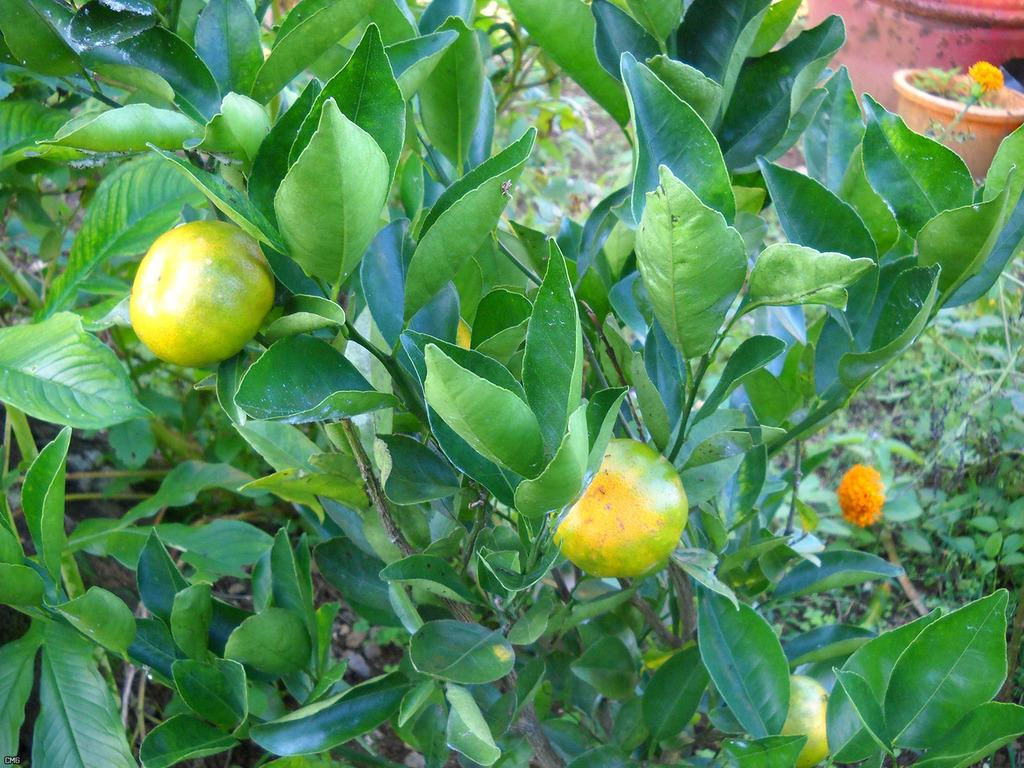What type of plants can be seen in the image? There are plants with flowers and plants with fruits in the image. What can be found in the background of the image? There are pots and grass in the background of the image. What type of news can be seen on the pizzas in the image? There are no pizzas present in the image, so there is no news on them. 